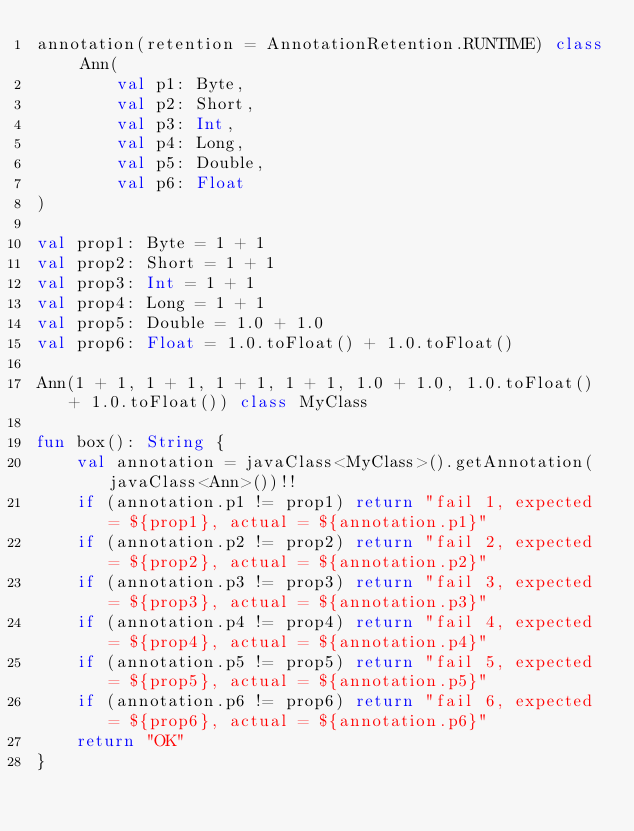<code> <loc_0><loc_0><loc_500><loc_500><_Kotlin_>annotation(retention = AnnotationRetention.RUNTIME) class Ann(
        val p1: Byte,
        val p2: Short,
        val p3: Int,
        val p4: Long,
        val p5: Double,
        val p6: Float
)

val prop1: Byte = 1 + 1
val prop2: Short = 1 + 1
val prop3: Int = 1 + 1
val prop4: Long = 1 + 1
val prop5: Double = 1.0 + 1.0
val prop6: Float = 1.0.toFloat() + 1.0.toFloat()

Ann(1 + 1, 1 + 1, 1 + 1, 1 + 1, 1.0 + 1.0, 1.0.toFloat() + 1.0.toFloat()) class MyClass

fun box(): String {
    val annotation = javaClass<MyClass>().getAnnotation(javaClass<Ann>())!!
    if (annotation.p1 != prop1) return "fail 1, expected = ${prop1}, actual = ${annotation.p1}"
    if (annotation.p2 != prop2) return "fail 2, expected = ${prop2}, actual = ${annotation.p2}"
    if (annotation.p3 != prop3) return "fail 3, expected = ${prop3}, actual = ${annotation.p3}"
    if (annotation.p4 != prop4) return "fail 4, expected = ${prop4}, actual = ${annotation.p4}"
    if (annotation.p5 != prop5) return "fail 5, expected = ${prop5}, actual = ${annotation.p5}"
    if (annotation.p6 != prop6) return "fail 6, expected = ${prop6}, actual = ${annotation.p6}"
    return "OK"
}</code> 